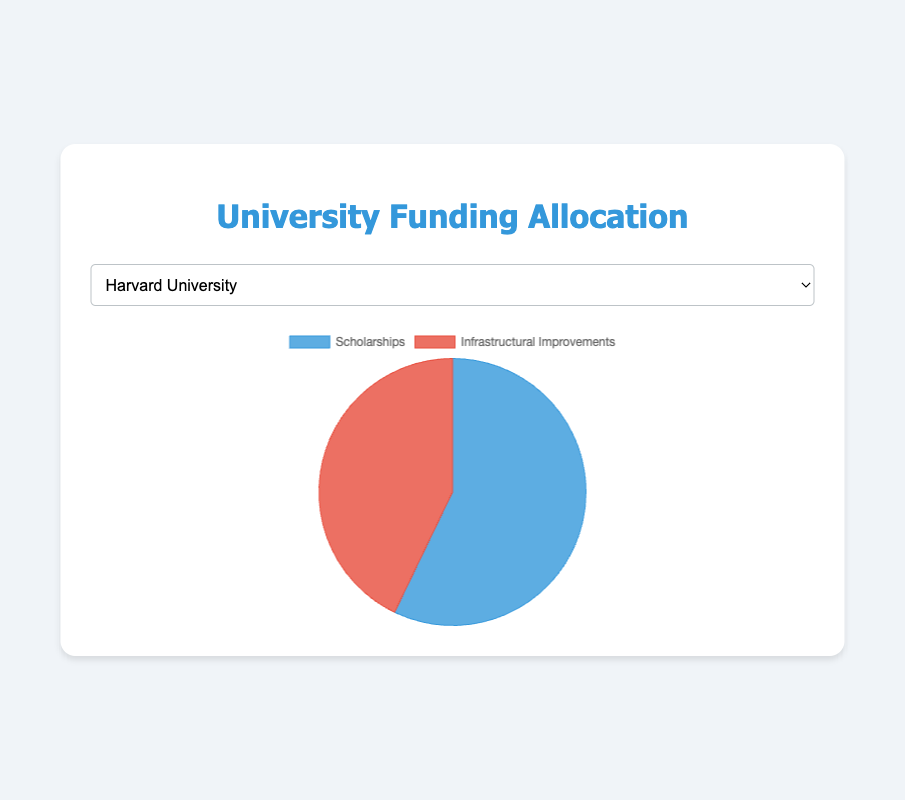Which category has a larger allocation at Harvard University? By looking at the pie chart for Harvard University, the segment for 'Scholarships' is larger than 'Infrastructural Improvements'. This indicates that more funding is allocated towards scholarships.
Answer: Scholarships What is the total funding allocation for Stanford University? To find the total funding allocation, sum the funds for both categories: $18,000,000 (Scholarships) + $17,000,000 (Infrastructural Improvements).
Answer: $35,000,000 Does Massachusetts Institute of Technology spend more on scholarships or infrastructural improvements? By looking at the pie chart, the segment 'Scholarships' is larger than 'Infrastructural Improvements'. This indicates more spending on scholarships.
Answer: Scholarships Compare the funding allocation for infrastructural improvements between Harvard University and University of California, Berkeley. Which university allocates more? By comparing the pie charts of both universities, Harvard University allocates $15,000,000 whereas University of California, Berkeley allocates $13,000,000 for infrastructural improvements. Harvard allocates more.
Answer: Harvard University What percentage of University of Oxford's funding is allocated to scholarships? The total funding for University of Oxford is $41,000,000 ($19,000,000 for Scholarships and $22,000,000 for Infrastructural Improvements). The percentage is (19/41) * 100 = 46.34%.
Answer: 46.34% What's the greatest single category funding allocation among all the universities? Examining all pie charts, the largest allocation is identified as 'Scholarships' for Massachusetts Institute of Technology at $22,000,000.
Answer: $22,000,000 Which university has the smallest funding allocation for infrastructural improvements? By examining the segments for infrastructural improvements across all universities, University of California, Berkeley has the smallest allocation at $13,000,000.
Answer: University of California, Berkeley 